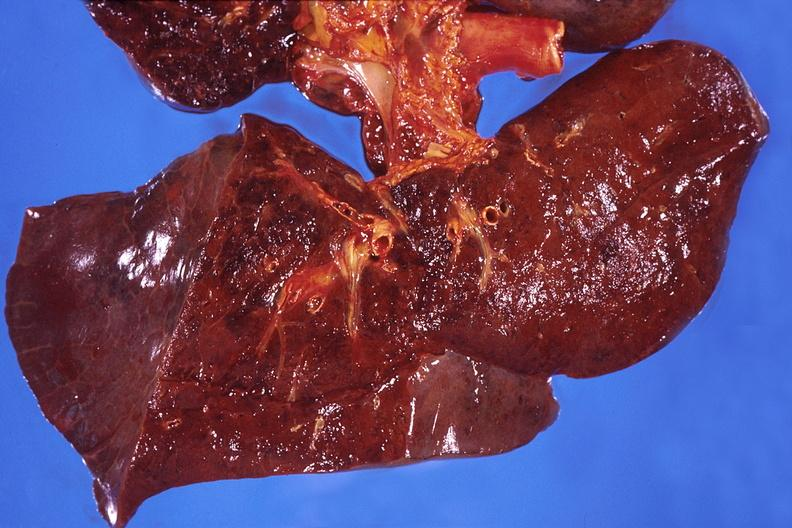s respiratory present?
Answer the question using a single word or phrase. Yes 